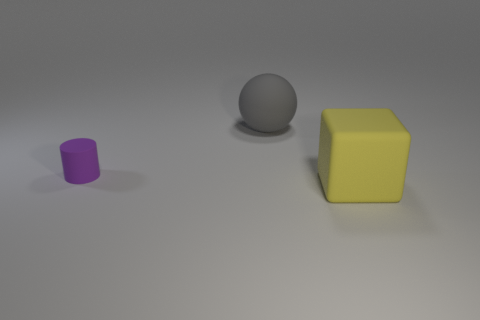Add 2 tiny matte cylinders. How many objects exist? 5 Subtract all cubes. How many objects are left? 2 Add 2 big yellow matte balls. How many big yellow matte balls exist? 2 Subtract 1 gray spheres. How many objects are left? 2 Subtract all large gray objects. Subtract all small rubber cylinders. How many objects are left? 1 Add 3 big matte balls. How many big matte balls are left? 4 